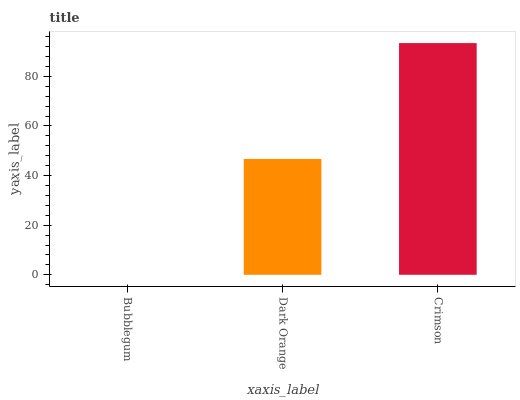Is Bubblegum the minimum?
Answer yes or no. Yes. Is Crimson the maximum?
Answer yes or no. Yes. Is Dark Orange the minimum?
Answer yes or no. No. Is Dark Orange the maximum?
Answer yes or no. No. Is Dark Orange greater than Bubblegum?
Answer yes or no. Yes. Is Bubblegum less than Dark Orange?
Answer yes or no. Yes. Is Bubblegum greater than Dark Orange?
Answer yes or no. No. Is Dark Orange less than Bubblegum?
Answer yes or no. No. Is Dark Orange the high median?
Answer yes or no. Yes. Is Dark Orange the low median?
Answer yes or no. Yes. Is Bubblegum the high median?
Answer yes or no. No. Is Bubblegum the low median?
Answer yes or no. No. 